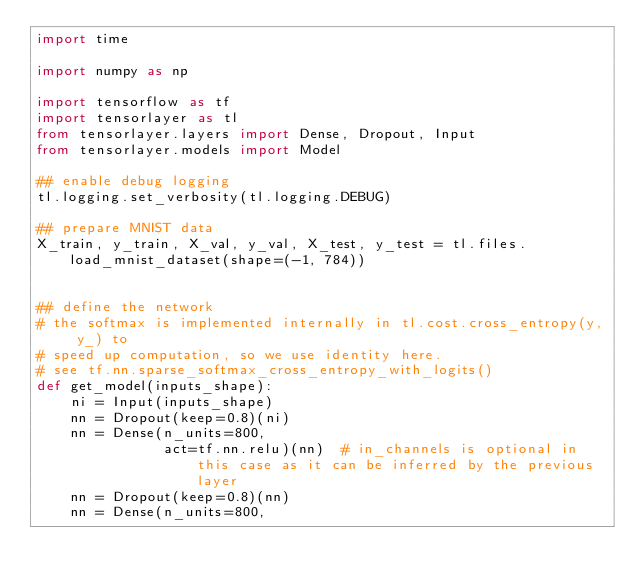Convert code to text. <code><loc_0><loc_0><loc_500><loc_500><_Python_>import time

import numpy as np

import tensorflow as tf
import tensorlayer as tl
from tensorlayer.layers import Dense, Dropout, Input
from tensorlayer.models import Model

## enable debug logging
tl.logging.set_verbosity(tl.logging.DEBUG)

## prepare MNIST data
X_train, y_train, X_val, y_val, X_test, y_test = tl.files.load_mnist_dataset(shape=(-1, 784))


## define the network
# the softmax is implemented internally in tl.cost.cross_entropy(y, y_) to
# speed up computation, so we use identity here.
# see tf.nn.sparse_softmax_cross_entropy_with_logits()
def get_model(inputs_shape):
    ni = Input(inputs_shape)
    nn = Dropout(keep=0.8)(ni)
    nn = Dense(n_units=800,
               act=tf.nn.relu)(nn)  # in_channels is optional in this case as it can be inferred by the previous layer
    nn = Dropout(keep=0.8)(nn)
    nn = Dense(n_units=800,</code> 